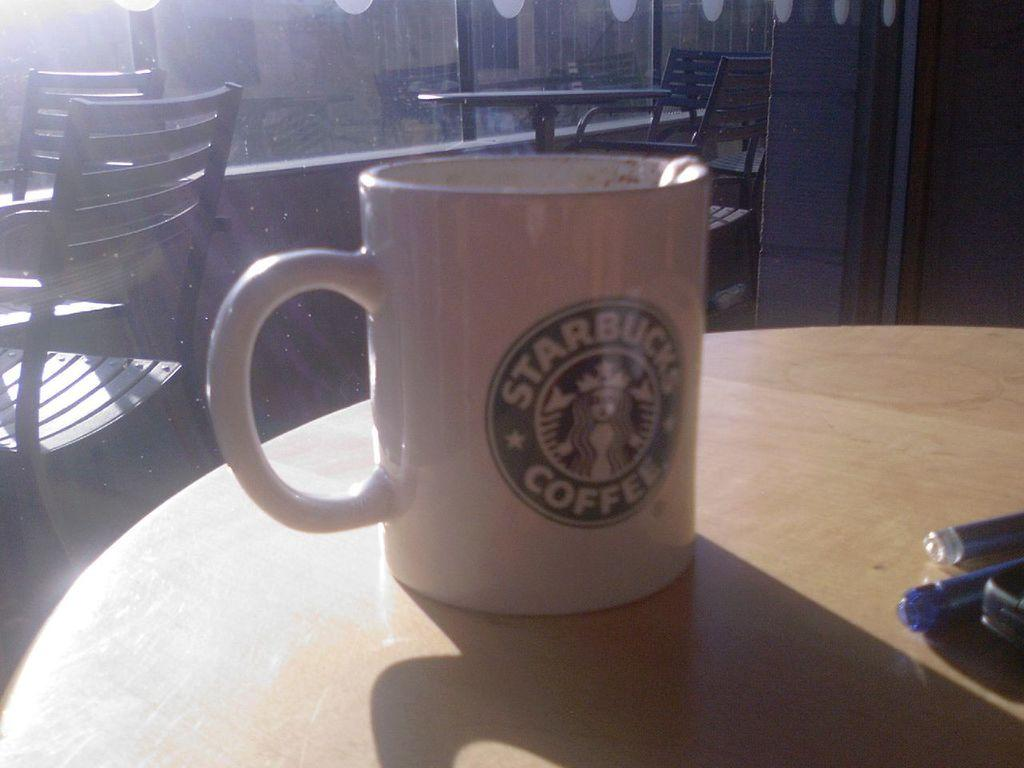<image>
Offer a succinct explanation of the picture presented. white starbucks coffee cup on a round wood table with windows in the background 